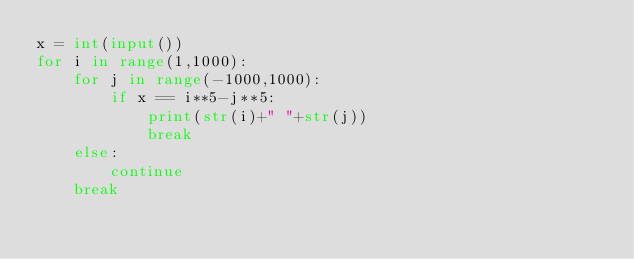<code> <loc_0><loc_0><loc_500><loc_500><_Python_>x = int(input())
for i in range(1,1000):
    for j in range(-1000,1000):
        if x == i**5-j**5:
            print(str(i)+" "+str(j))
            break
    else:
        continue
    break
</code> 